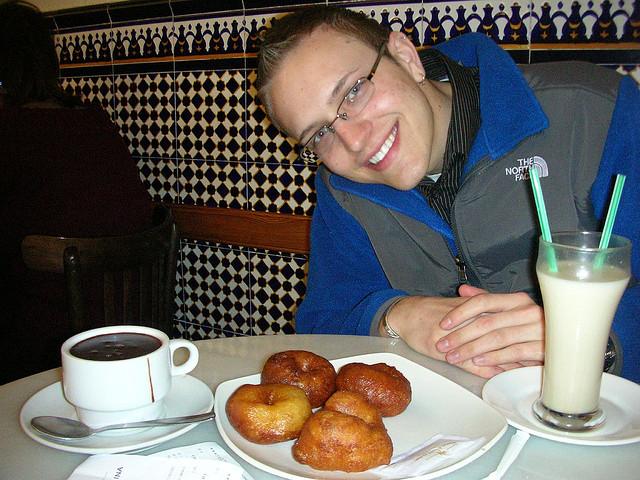Is there a coffee cup on the table?
Concise answer only. Yes. Is the man happy?
Give a very brief answer. Yes. How many straws are in the picture?
Concise answer only. 2. 